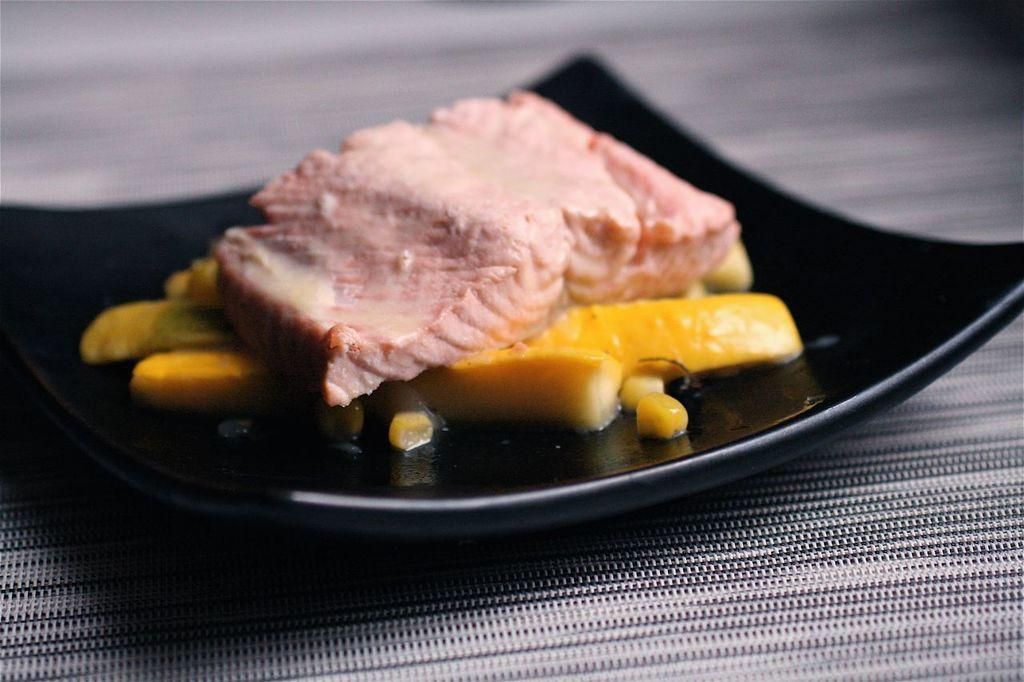What piece of furniture is present in the image? There is a table in the image. What is placed on the table? There is a plate on the table. What is in the plate? There is a food item in the plate. What type of yak can be seen using the appliance in the image? There is no yak or appliance present in the image. 